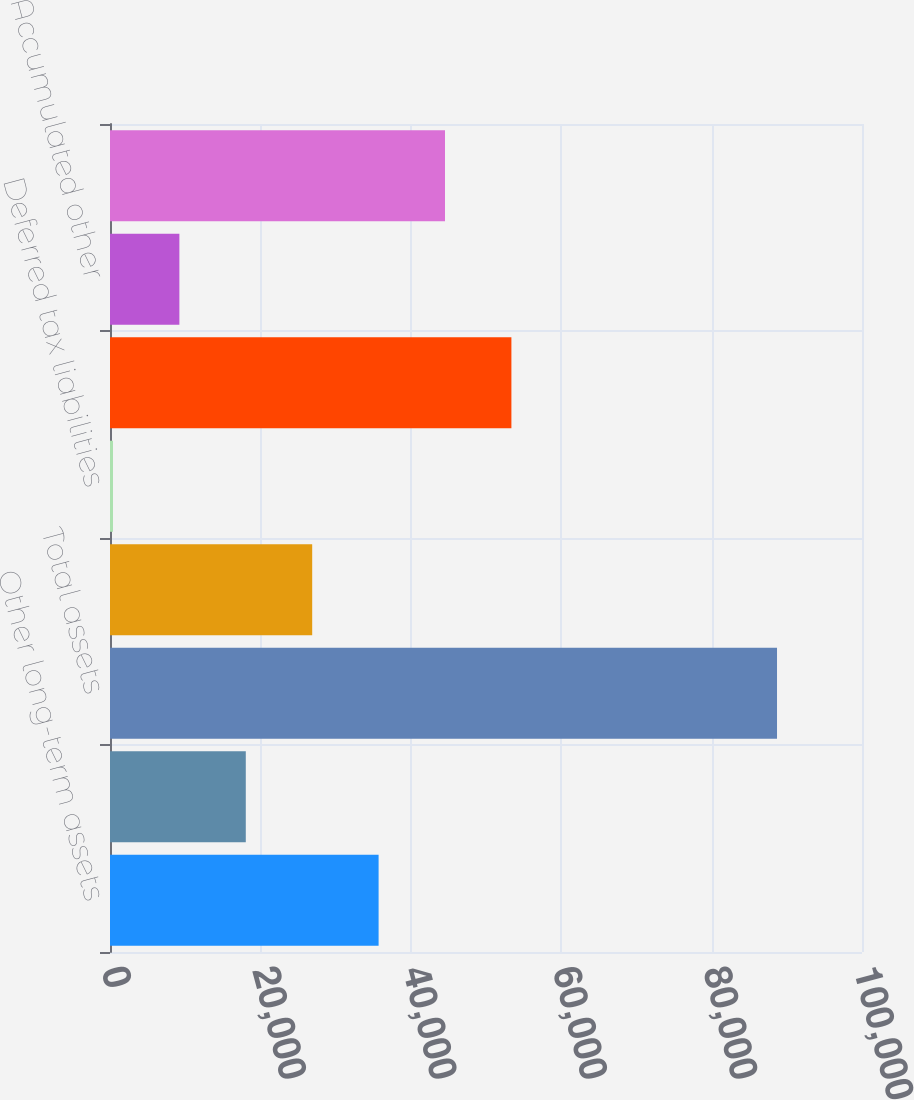Convert chart. <chart><loc_0><loc_0><loc_500><loc_500><bar_chart><fcel>Other long-term assets<fcel>Deferred tax assets long-term<fcel>Total assets<fcel>Pension post-retirement and<fcel>Deferred tax liabilities<fcel>Total liabilities<fcel>Accumulated other<fcel>Total stockholders' equity<nl><fcel>35717.8<fcel>18057.4<fcel>88699<fcel>26887.6<fcel>397<fcel>53378.2<fcel>9227.2<fcel>44548<nl></chart> 